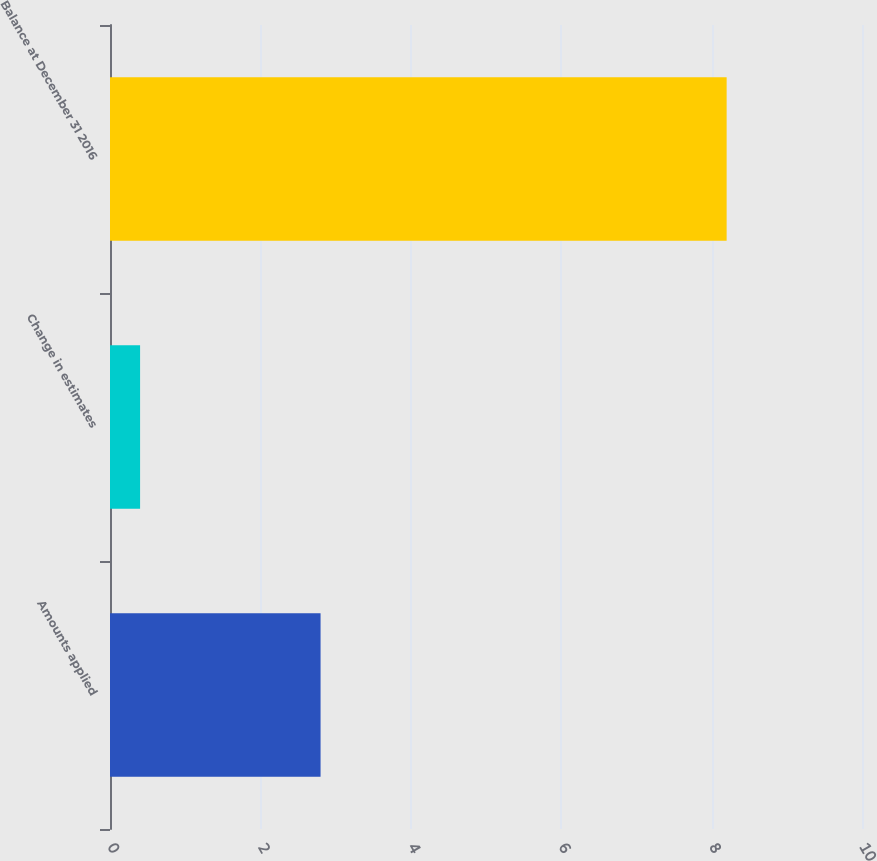Convert chart to OTSL. <chart><loc_0><loc_0><loc_500><loc_500><bar_chart><fcel>Amounts applied<fcel>Change in estimates<fcel>Balance at December 31 2016<nl><fcel>2.8<fcel>0.4<fcel>8.2<nl></chart> 